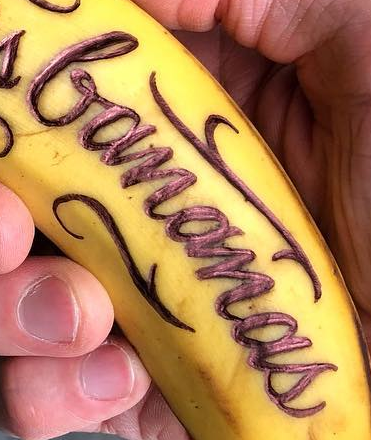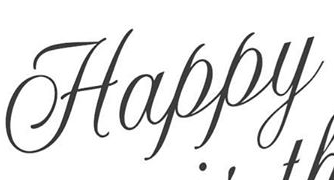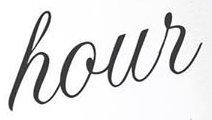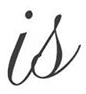Identify the words shown in these images in order, separated by a semicolon. bananas; Happy; hour; is 